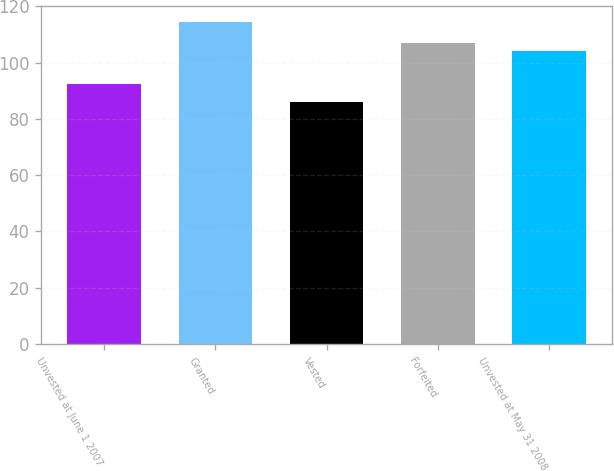Convert chart. <chart><loc_0><loc_0><loc_500><loc_500><bar_chart><fcel>Unvested at June 1 2007<fcel>Granted<fcel>Vested<fcel>Forfeited<fcel>Unvested at May 31 2008<nl><fcel>92.37<fcel>114.4<fcel>86.16<fcel>106.79<fcel>103.97<nl></chart> 